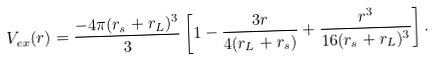<formula> <loc_0><loc_0><loc_500><loc_500>V _ { e x } ( r ) = \frac { - 4 \pi ( r _ { s } + r _ { L } ) ^ { 3 } } { 3 } \left [ 1 - \frac { 3 r } { 4 ( r _ { L } + r _ { s } ) } + \frac { r ^ { 3 } } { 1 6 ( r _ { s } + r _ { L } ) ^ { 3 } } \right ] .</formula> 